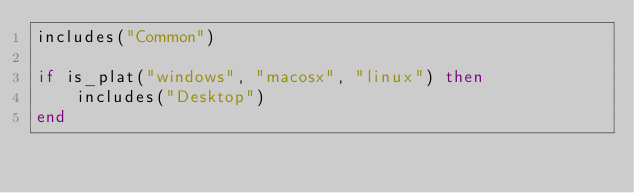<code> <loc_0><loc_0><loc_500><loc_500><_Lua_>includes("Common")

if is_plat("windows", "macosx", "linux") then
    includes("Desktop")
end
</code> 